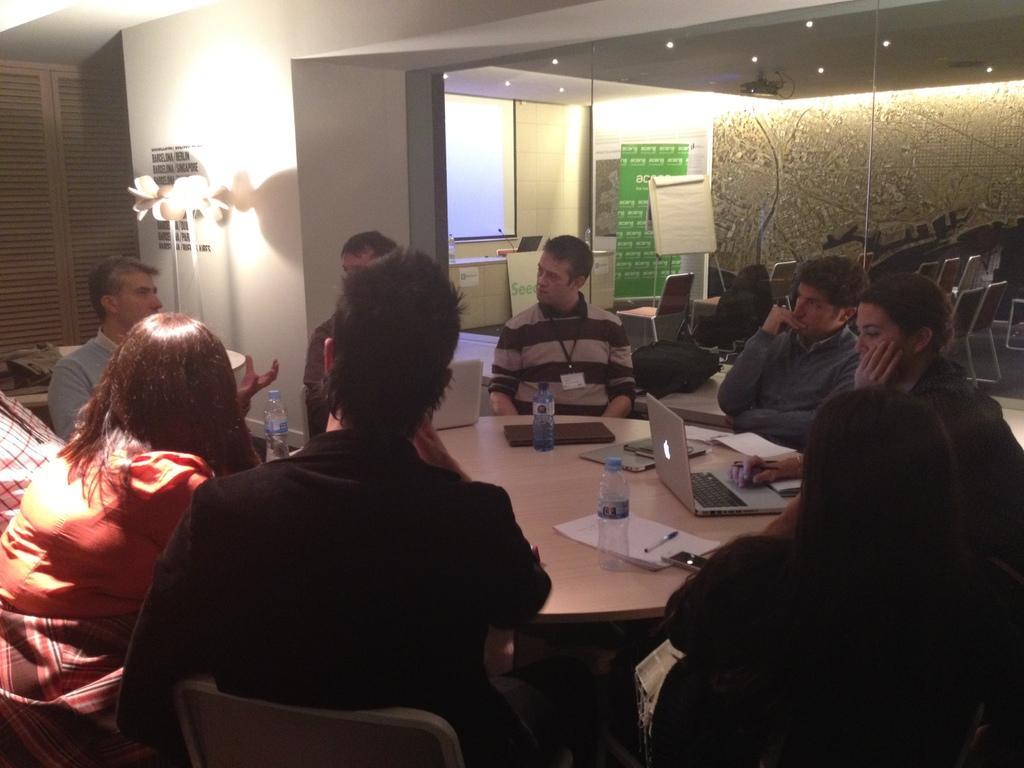Please provide a concise description of this image. In this picture there are group of people sitting in chairs and in table there are bottle , laptop, paper , pen ,book and in back ground we have light , window , board , and a hoarding and a projector. 